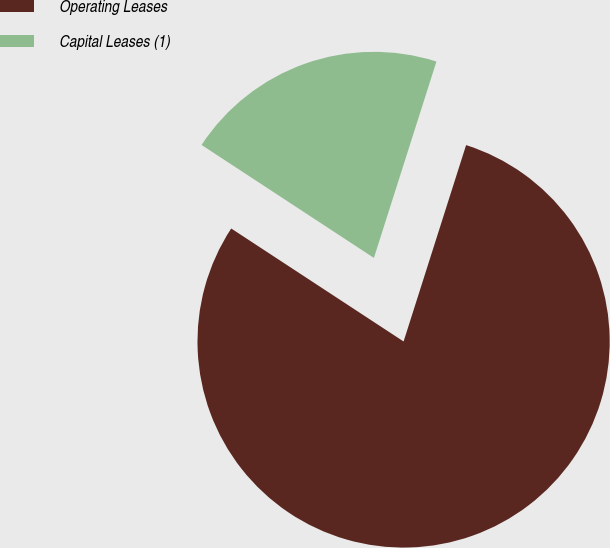<chart> <loc_0><loc_0><loc_500><loc_500><pie_chart><fcel>Operating Leases<fcel>Capital Leases (1)<nl><fcel>79.33%<fcel>20.67%<nl></chart> 